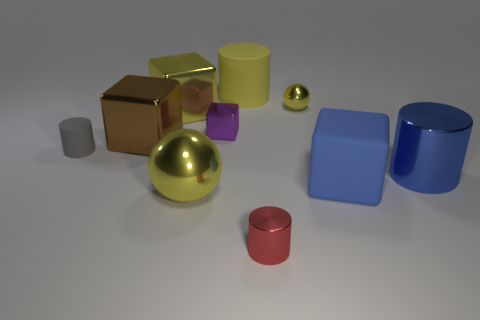Subtract all balls. How many objects are left? 8 Add 3 small metal cylinders. How many small metal cylinders are left? 4 Add 2 small gray objects. How many small gray objects exist? 3 Subtract 0 brown spheres. How many objects are left? 10 Subtract all purple blocks. Subtract all small purple things. How many objects are left? 8 